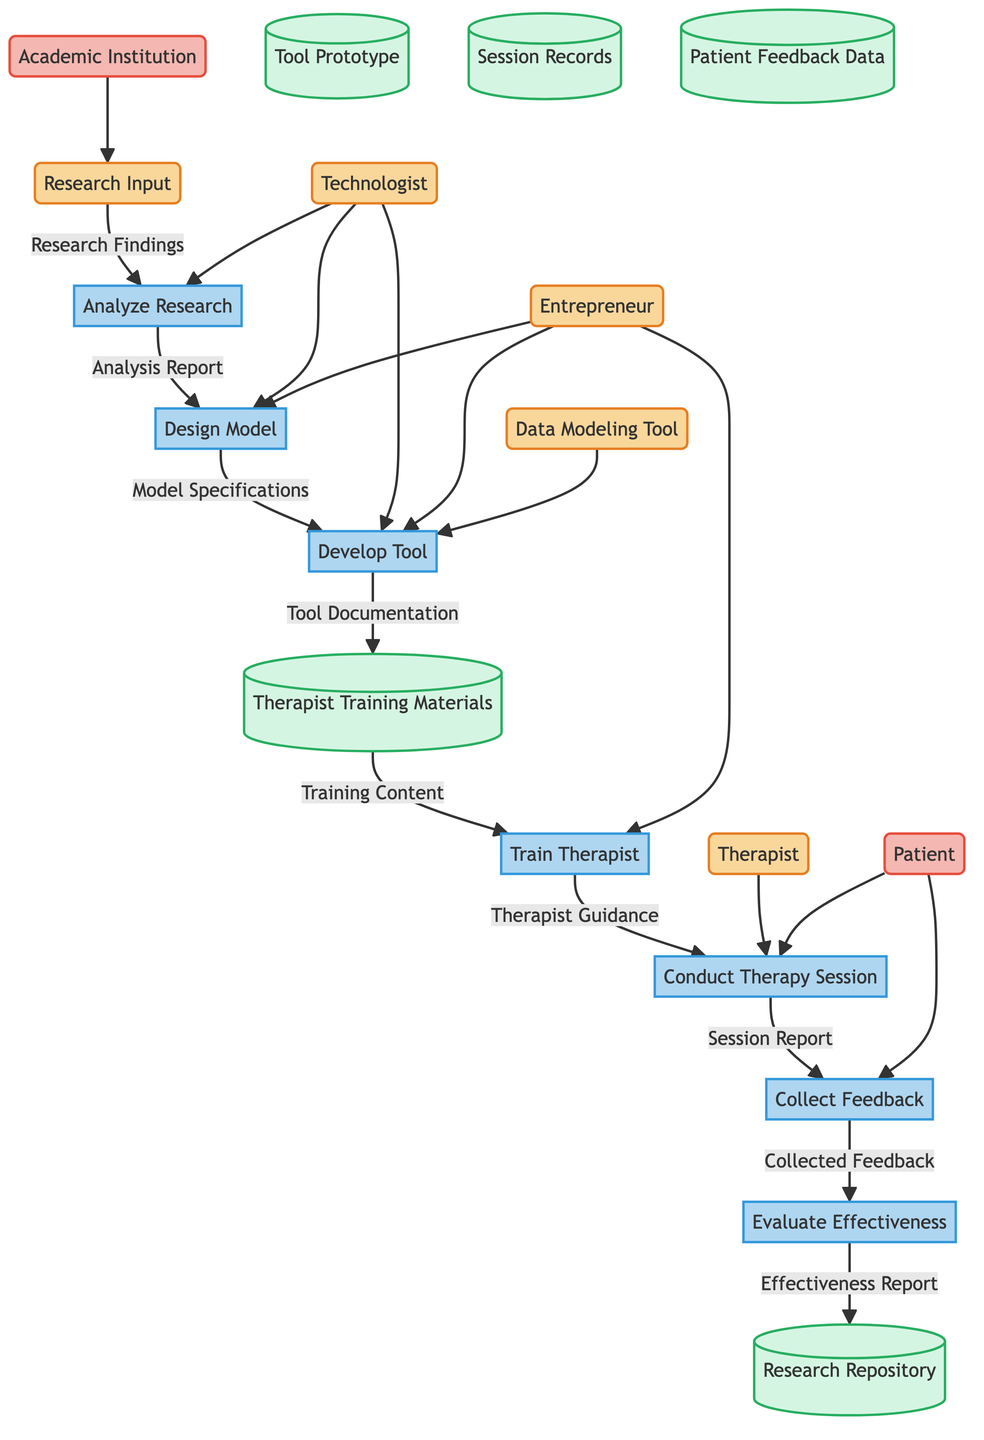What is the first process in the diagram? The first process in the diagram is represented by the node labeled "Analyze Research". This node is directly connected to the "Research Input" entity node, indicating its position as the starting point for processing research findings.
Answer: Analyze Research How many external entities are present in the diagram? The diagram includes two external entities. These are the "Patient" and the "Academic Institution". They are represented by distinct nodes outside the main flow of processes.
Answer: 2 Which data store receives the effectiveness report? The effectiveness report is directed to the "Research Repository" data store. This relationship is indicated by the flow labeled "Effectiveness Report" that connects the "Evaluate Effectiveness" process to the "Research Repository".
Answer: Research Repository What is the role of the Technologist in the diagram? The Technologist is involved in multiple processes, namely "Analyze Research", "Design Model", and "Develop Tool". The flows from the Technologist to these processes indicate their supportive role in analyzing the research findings and designing a practical model.
Answer: Analyze Research, Design Model, Develop Tool Which process collects feedback after conducting a therapy session? The process that collects feedback is called "Collect Feedback". This process receives input from the "Conduct Therapy Session" process, as shown by the flow labeled "Session Report".
Answer: Collect Feedback What type of document is produced after the "Design Model" process? The document produced after the "Design Model" process is referred to as "Model Specifications". This is shown as the output flow from the "Design Model" to the "Develop Tool" process, indicating that it informs tool development.
Answer: Model Specifications Who receives the training content in the diagram? The training content is directed to the "Therapist". This relationship is shown by the flow labeled "Training Content" that connects the "Therapist Training Materials" data store with the "Train Therapist" process, which ultimately leads to the therapist's guidance during therapy sessions.
Answer: Therapist What is the final data flow out of the diagram? The final data flow is labeled "Effectiveness Report", which flows from the "Evaluate Effectiveness" process to the "Research Repository". This indicates that the evaluation of therapy effectiveness culminates in a report which is stored in the research repository.
Answer: Effectiveness Report What is the purpose of the "Develop Tool" process? The purpose of the "Develop Tool" process is to create a therapy tool based on the model specifications received from the previous process, "Design Model". It synthesizes the generated model into a functional tool for therapy application.
Answer: Develop Therapy Tool 